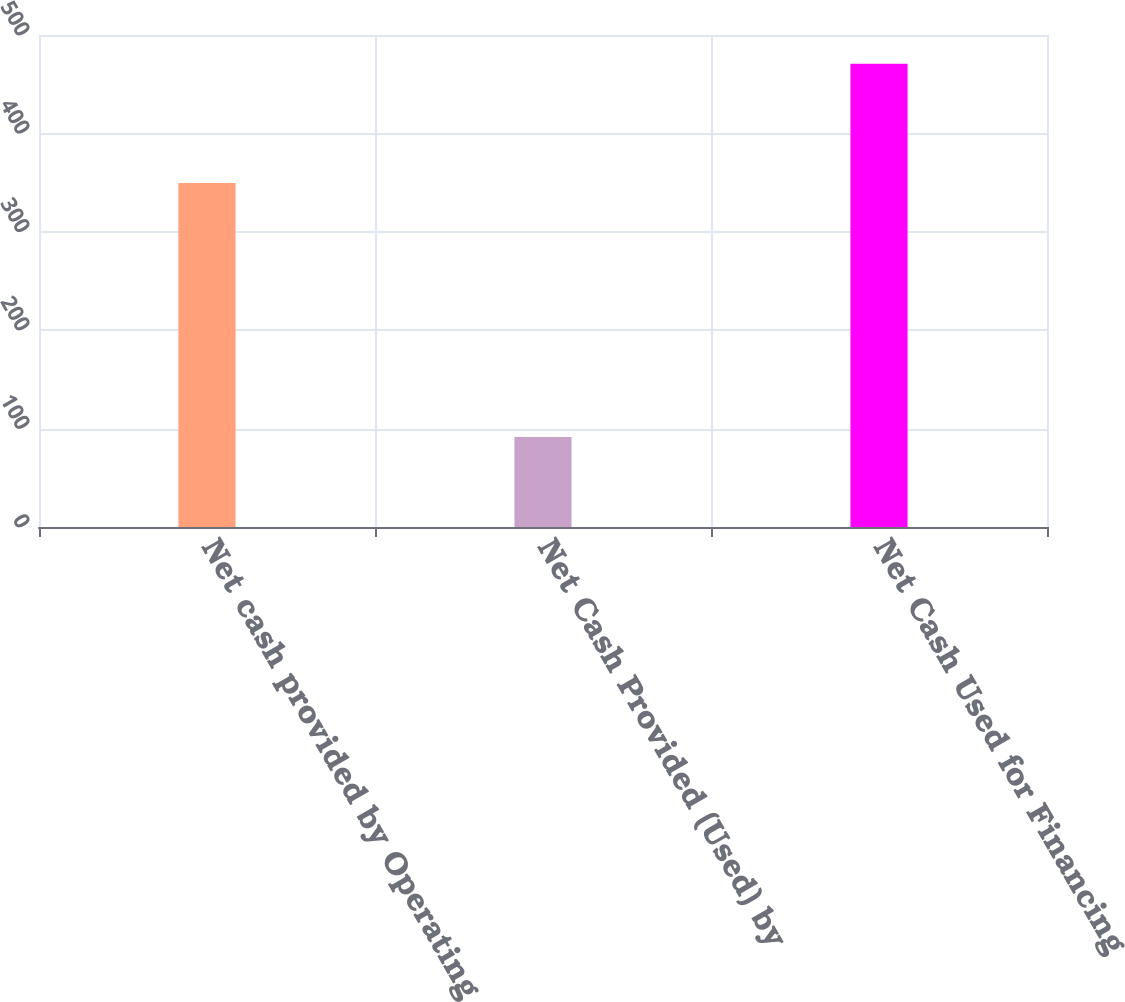Convert chart to OTSL. <chart><loc_0><loc_0><loc_500><loc_500><bar_chart><fcel>Net cash provided by Operating<fcel>Net Cash Provided (Used) by<fcel>Net Cash Used for Financing<nl><fcel>349.7<fcel>91.5<fcel>470.9<nl></chart> 